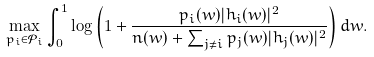Convert formula to latex. <formula><loc_0><loc_0><loc_500><loc_500>& \max _ { p _ { i } \in \mathcal { P } _ { i } } \int _ { 0 } ^ { 1 } \log \left ( 1 + \frac { { p } _ { i } ( w ) | h _ { i } ( w ) | ^ { 2 } } { n ( w ) + \sum _ { j \ne i } { p } _ { j } ( w ) | h _ { j } ( w ) | ^ { 2 } } \right ) d w .</formula> 